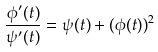<formula> <loc_0><loc_0><loc_500><loc_500>\frac { \phi ^ { \prime } ( t ) } { \psi ^ { \prime } ( t ) } = \psi ( t ) + ( \phi ( t ) ) ^ { 2 }</formula> 